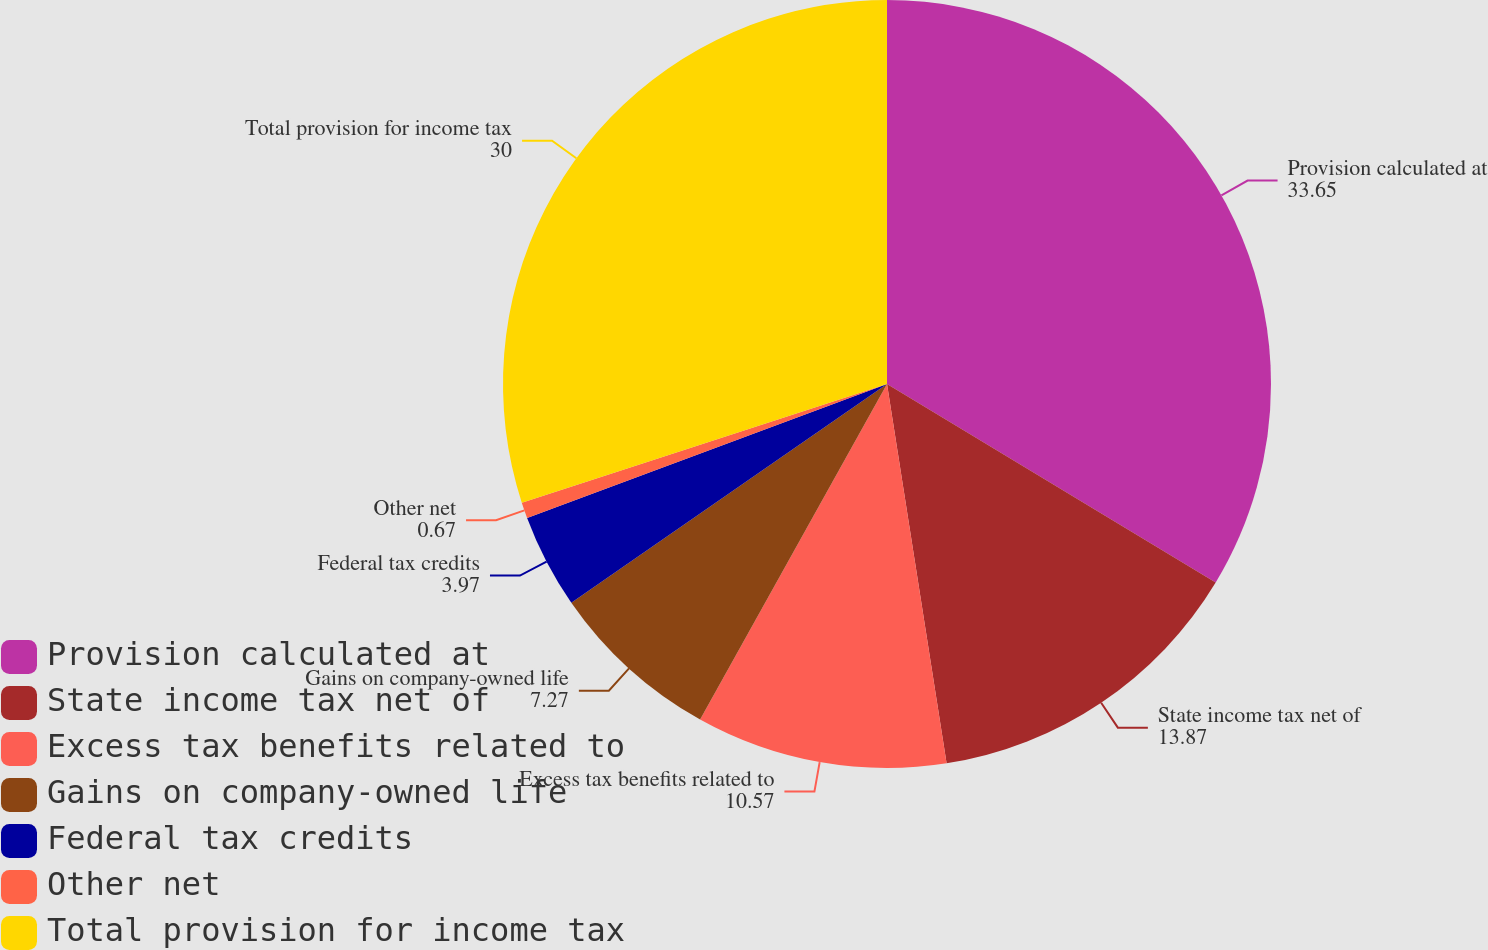Convert chart. <chart><loc_0><loc_0><loc_500><loc_500><pie_chart><fcel>Provision calculated at<fcel>State income tax net of<fcel>Excess tax benefits related to<fcel>Gains on company-owned life<fcel>Federal tax credits<fcel>Other net<fcel>Total provision for income tax<nl><fcel>33.65%<fcel>13.87%<fcel>10.57%<fcel>7.27%<fcel>3.97%<fcel>0.67%<fcel>30.0%<nl></chart> 